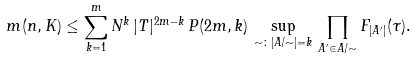<formula> <loc_0><loc_0><loc_500><loc_500>m ( n , K ) \leq \sum _ { k = 1 } ^ { m } N ^ { k } \, | T | ^ { 2 m - k } \, P ( 2 m , k ) \, \sup _ { \sim \colon | A / \sim | = k } \, \prod _ { A ^ { \prime } \in A / \sim } F _ { | A ^ { \prime } | } ( \tau ) .</formula> 